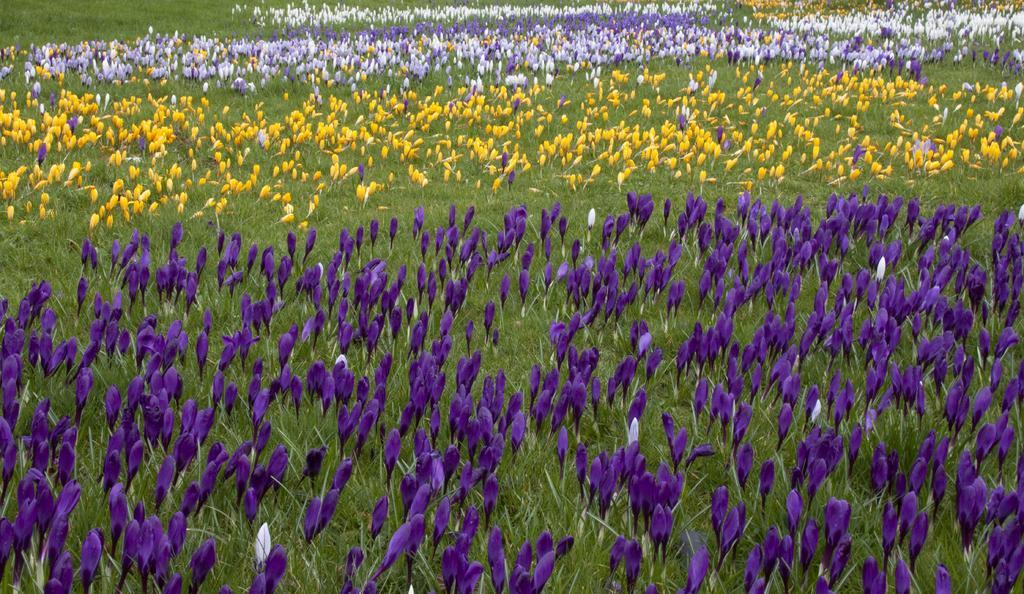Can you describe this image briefly? In the picture we can see a grass surface on it, we can see grass plants and flowers to it which are blue in color, white, yellow and violet color. 